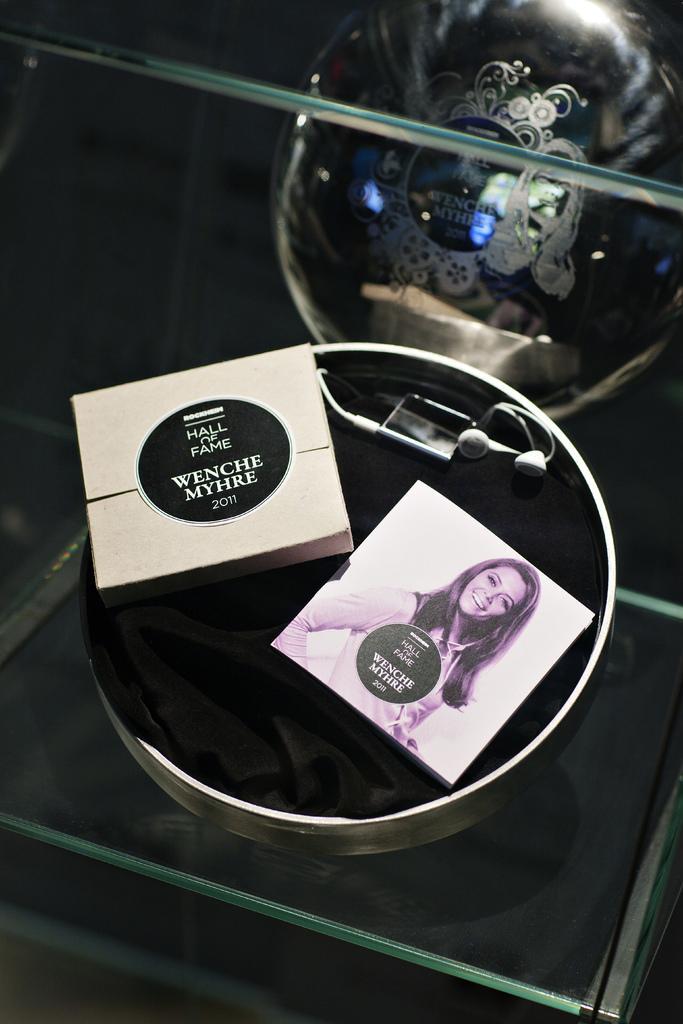In one or two sentences, can you explain what this image depicts? In this image I can see the steel bowl on the glass. In the bowl I can see the black color cloth, two boxes and the earphones. To the side I can see another box. 